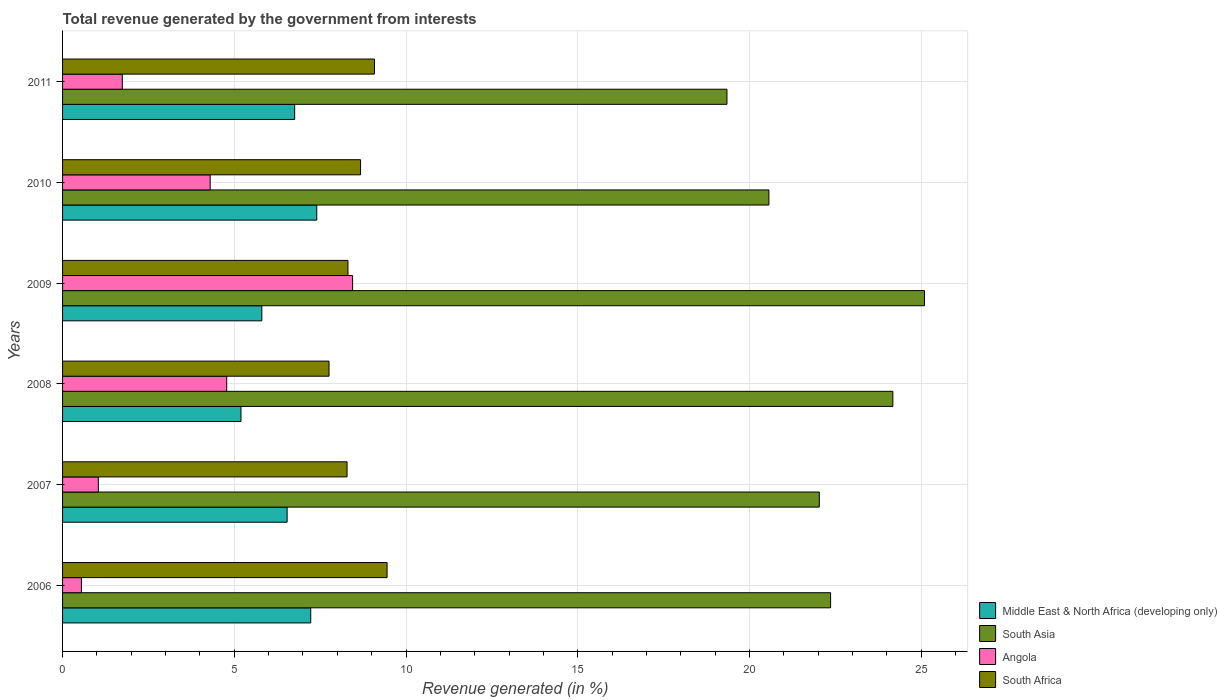Are the number of bars per tick equal to the number of legend labels?
Your answer should be very brief. Yes. Are the number of bars on each tick of the Y-axis equal?
Ensure brevity in your answer.  Yes. How many bars are there on the 1st tick from the top?
Offer a very short reply. 4. What is the total revenue generated in Angola in 2009?
Offer a terse response. 8.44. Across all years, what is the maximum total revenue generated in Middle East & North Africa (developing only)?
Ensure brevity in your answer.  7.4. Across all years, what is the minimum total revenue generated in South Asia?
Keep it short and to the point. 19.34. What is the total total revenue generated in South Africa in the graph?
Provide a succinct answer. 51.56. What is the difference between the total revenue generated in South Asia in 2007 and that in 2010?
Your answer should be very brief. 1.47. What is the difference between the total revenue generated in Middle East & North Africa (developing only) in 2010 and the total revenue generated in Angola in 2009?
Ensure brevity in your answer.  -1.04. What is the average total revenue generated in South Africa per year?
Offer a terse response. 8.59. In the year 2009, what is the difference between the total revenue generated in Middle East & North Africa (developing only) and total revenue generated in South Africa?
Provide a succinct answer. -2.51. What is the ratio of the total revenue generated in South Asia in 2009 to that in 2010?
Ensure brevity in your answer.  1.22. What is the difference between the highest and the second highest total revenue generated in South Asia?
Give a very brief answer. 0.92. What is the difference between the highest and the lowest total revenue generated in South Africa?
Your answer should be compact. 1.69. In how many years, is the total revenue generated in Angola greater than the average total revenue generated in Angola taken over all years?
Make the answer very short. 3. What does the 1st bar from the top in 2008 represents?
Your response must be concise. South Africa. Is it the case that in every year, the sum of the total revenue generated in South Africa and total revenue generated in Angola is greater than the total revenue generated in Middle East & North Africa (developing only)?
Your response must be concise. Yes. Are the values on the major ticks of X-axis written in scientific E-notation?
Provide a succinct answer. No. Where does the legend appear in the graph?
Ensure brevity in your answer.  Bottom right. How are the legend labels stacked?
Offer a very short reply. Vertical. What is the title of the graph?
Keep it short and to the point. Total revenue generated by the government from interests. What is the label or title of the X-axis?
Offer a very short reply. Revenue generated (in %). What is the Revenue generated (in %) in Middle East & North Africa (developing only) in 2006?
Your answer should be very brief. 7.23. What is the Revenue generated (in %) in South Asia in 2006?
Your answer should be compact. 22.36. What is the Revenue generated (in %) of Angola in 2006?
Offer a terse response. 0.55. What is the Revenue generated (in %) in South Africa in 2006?
Offer a terse response. 9.45. What is the Revenue generated (in %) of Middle East & North Africa (developing only) in 2007?
Your answer should be compact. 6.54. What is the Revenue generated (in %) in South Asia in 2007?
Make the answer very short. 22.03. What is the Revenue generated (in %) of Angola in 2007?
Offer a very short reply. 1.04. What is the Revenue generated (in %) of South Africa in 2007?
Your response must be concise. 8.28. What is the Revenue generated (in %) in Middle East & North Africa (developing only) in 2008?
Make the answer very short. 5.19. What is the Revenue generated (in %) of South Asia in 2008?
Your answer should be very brief. 24.17. What is the Revenue generated (in %) of Angola in 2008?
Provide a short and direct response. 4.78. What is the Revenue generated (in %) in South Africa in 2008?
Provide a succinct answer. 7.76. What is the Revenue generated (in %) of Middle East & North Africa (developing only) in 2009?
Offer a terse response. 5.8. What is the Revenue generated (in %) in South Asia in 2009?
Make the answer very short. 25.1. What is the Revenue generated (in %) in Angola in 2009?
Keep it short and to the point. 8.44. What is the Revenue generated (in %) in South Africa in 2009?
Your answer should be very brief. 8.31. What is the Revenue generated (in %) in Middle East & North Africa (developing only) in 2010?
Your answer should be very brief. 7.4. What is the Revenue generated (in %) of South Asia in 2010?
Provide a short and direct response. 20.57. What is the Revenue generated (in %) of Angola in 2010?
Keep it short and to the point. 4.3. What is the Revenue generated (in %) of South Africa in 2010?
Provide a succinct answer. 8.68. What is the Revenue generated (in %) in Middle East & North Africa (developing only) in 2011?
Keep it short and to the point. 6.76. What is the Revenue generated (in %) in South Asia in 2011?
Your response must be concise. 19.34. What is the Revenue generated (in %) of Angola in 2011?
Offer a very short reply. 1.74. What is the Revenue generated (in %) in South Africa in 2011?
Your answer should be very brief. 9.08. Across all years, what is the maximum Revenue generated (in %) in Middle East & North Africa (developing only)?
Give a very brief answer. 7.4. Across all years, what is the maximum Revenue generated (in %) of South Asia?
Ensure brevity in your answer.  25.1. Across all years, what is the maximum Revenue generated (in %) in Angola?
Offer a very short reply. 8.44. Across all years, what is the maximum Revenue generated (in %) in South Africa?
Provide a succinct answer. 9.45. Across all years, what is the minimum Revenue generated (in %) in Middle East & North Africa (developing only)?
Keep it short and to the point. 5.19. Across all years, what is the minimum Revenue generated (in %) of South Asia?
Keep it short and to the point. 19.34. Across all years, what is the minimum Revenue generated (in %) in Angola?
Provide a succinct answer. 0.55. Across all years, what is the minimum Revenue generated (in %) in South Africa?
Offer a very short reply. 7.76. What is the total Revenue generated (in %) in Middle East & North Africa (developing only) in the graph?
Offer a very short reply. 38.92. What is the total Revenue generated (in %) of South Asia in the graph?
Make the answer very short. 133.57. What is the total Revenue generated (in %) of Angola in the graph?
Offer a terse response. 20.85. What is the total Revenue generated (in %) in South Africa in the graph?
Offer a very short reply. 51.56. What is the difference between the Revenue generated (in %) in Middle East & North Africa (developing only) in 2006 and that in 2007?
Provide a short and direct response. 0.69. What is the difference between the Revenue generated (in %) in South Asia in 2006 and that in 2007?
Your answer should be very brief. 0.33. What is the difference between the Revenue generated (in %) of Angola in 2006 and that in 2007?
Your response must be concise. -0.49. What is the difference between the Revenue generated (in %) in South Africa in 2006 and that in 2007?
Ensure brevity in your answer.  1.17. What is the difference between the Revenue generated (in %) of Middle East & North Africa (developing only) in 2006 and that in 2008?
Give a very brief answer. 2.03. What is the difference between the Revenue generated (in %) in South Asia in 2006 and that in 2008?
Your answer should be very brief. -1.81. What is the difference between the Revenue generated (in %) of Angola in 2006 and that in 2008?
Keep it short and to the point. -4.23. What is the difference between the Revenue generated (in %) in South Africa in 2006 and that in 2008?
Make the answer very short. 1.69. What is the difference between the Revenue generated (in %) in Middle East & North Africa (developing only) in 2006 and that in 2009?
Give a very brief answer. 1.42. What is the difference between the Revenue generated (in %) of South Asia in 2006 and that in 2009?
Your answer should be compact. -2.73. What is the difference between the Revenue generated (in %) in Angola in 2006 and that in 2009?
Your answer should be compact. -7.89. What is the difference between the Revenue generated (in %) in South Africa in 2006 and that in 2009?
Provide a succinct answer. 1.14. What is the difference between the Revenue generated (in %) of Middle East & North Africa (developing only) in 2006 and that in 2010?
Offer a very short reply. -0.17. What is the difference between the Revenue generated (in %) in South Asia in 2006 and that in 2010?
Offer a very short reply. 1.8. What is the difference between the Revenue generated (in %) of Angola in 2006 and that in 2010?
Your response must be concise. -3.75. What is the difference between the Revenue generated (in %) in South Africa in 2006 and that in 2010?
Your answer should be very brief. 0.77. What is the difference between the Revenue generated (in %) in Middle East & North Africa (developing only) in 2006 and that in 2011?
Ensure brevity in your answer.  0.47. What is the difference between the Revenue generated (in %) of South Asia in 2006 and that in 2011?
Provide a short and direct response. 3.02. What is the difference between the Revenue generated (in %) of Angola in 2006 and that in 2011?
Your answer should be compact. -1.19. What is the difference between the Revenue generated (in %) of South Africa in 2006 and that in 2011?
Give a very brief answer. 0.37. What is the difference between the Revenue generated (in %) of Middle East & North Africa (developing only) in 2007 and that in 2008?
Your answer should be compact. 1.34. What is the difference between the Revenue generated (in %) of South Asia in 2007 and that in 2008?
Ensure brevity in your answer.  -2.14. What is the difference between the Revenue generated (in %) of Angola in 2007 and that in 2008?
Your response must be concise. -3.74. What is the difference between the Revenue generated (in %) of South Africa in 2007 and that in 2008?
Provide a short and direct response. 0.52. What is the difference between the Revenue generated (in %) of Middle East & North Africa (developing only) in 2007 and that in 2009?
Offer a very short reply. 0.74. What is the difference between the Revenue generated (in %) in South Asia in 2007 and that in 2009?
Make the answer very short. -3.06. What is the difference between the Revenue generated (in %) in Angola in 2007 and that in 2009?
Give a very brief answer. -7.4. What is the difference between the Revenue generated (in %) in South Africa in 2007 and that in 2009?
Provide a short and direct response. -0.03. What is the difference between the Revenue generated (in %) of Middle East & North Africa (developing only) in 2007 and that in 2010?
Your answer should be compact. -0.86. What is the difference between the Revenue generated (in %) in South Asia in 2007 and that in 2010?
Give a very brief answer. 1.47. What is the difference between the Revenue generated (in %) of Angola in 2007 and that in 2010?
Keep it short and to the point. -3.26. What is the difference between the Revenue generated (in %) of South Africa in 2007 and that in 2010?
Offer a terse response. -0.39. What is the difference between the Revenue generated (in %) in Middle East & North Africa (developing only) in 2007 and that in 2011?
Provide a short and direct response. -0.22. What is the difference between the Revenue generated (in %) of South Asia in 2007 and that in 2011?
Keep it short and to the point. 2.69. What is the difference between the Revenue generated (in %) in Angola in 2007 and that in 2011?
Your answer should be very brief. -0.7. What is the difference between the Revenue generated (in %) of South Africa in 2007 and that in 2011?
Ensure brevity in your answer.  -0.8. What is the difference between the Revenue generated (in %) of Middle East & North Africa (developing only) in 2008 and that in 2009?
Ensure brevity in your answer.  -0.61. What is the difference between the Revenue generated (in %) of South Asia in 2008 and that in 2009?
Ensure brevity in your answer.  -0.92. What is the difference between the Revenue generated (in %) in Angola in 2008 and that in 2009?
Provide a succinct answer. -3.66. What is the difference between the Revenue generated (in %) in South Africa in 2008 and that in 2009?
Offer a very short reply. -0.55. What is the difference between the Revenue generated (in %) in Middle East & North Africa (developing only) in 2008 and that in 2010?
Give a very brief answer. -2.21. What is the difference between the Revenue generated (in %) in South Asia in 2008 and that in 2010?
Offer a very short reply. 3.61. What is the difference between the Revenue generated (in %) in Angola in 2008 and that in 2010?
Offer a terse response. 0.48. What is the difference between the Revenue generated (in %) in South Africa in 2008 and that in 2010?
Provide a short and direct response. -0.92. What is the difference between the Revenue generated (in %) of Middle East & North Africa (developing only) in 2008 and that in 2011?
Ensure brevity in your answer.  -1.56. What is the difference between the Revenue generated (in %) of South Asia in 2008 and that in 2011?
Provide a succinct answer. 4.83. What is the difference between the Revenue generated (in %) in Angola in 2008 and that in 2011?
Give a very brief answer. 3.04. What is the difference between the Revenue generated (in %) in South Africa in 2008 and that in 2011?
Your answer should be compact. -1.32. What is the difference between the Revenue generated (in %) in Middle East & North Africa (developing only) in 2009 and that in 2010?
Give a very brief answer. -1.6. What is the difference between the Revenue generated (in %) in South Asia in 2009 and that in 2010?
Offer a terse response. 4.53. What is the difference between the Revenue generated (in %) in Angola in 2009 and that in 2010?
Give a very brief answer. 4.15. What is the difference between the Revenue generated (in %) in South Africa in 2009 and that in 2010?
Offer a very short reply. -0.37. What is the difference between the Revenue generated (in %) in Middle East & North Africa (developing only) in 2009 and that in 2011?
Your response must be concise. -0.96. What is the difference between the Revenue generated (in %) in South Asia in 2009 and that in 2011?
Give a very brief answer. 5.75. What is the difference between the Revenue generated (in %) of Angola in 2009 and that in 2011?
Offer a terse response. 6.7. What is the difference between the Revenue generated (in %) of South Africa in 2009 and that in 2011?
Give a very brief answer. -0.77. What is the difference between the Revenue generated (in %) in Middle East & North Africa (developing only) in 2010 and that in 2011?
Offer a very short reply. 0.64. What is the difference between the Revenue generated (in %) of South Asia in 2010 and that in 2011?
Your answer should be compact. 1.22. What is the difference between the Revenue generated (in %) in Angola in 2010 and that in 2011?
Provide a succinct answer. 2.56. What is the difference between the Revenue generated (in %) in South Africa in 2010 and that in 2011?
Keep it short and to the point. -0.41. What is the difference between the Revenue generated (in %) of Middle East & North Africa (developing only) in 2006 and the Revenue generated (in %) of South Asia in 2007?
Provide a succinct answer. -14.81. What is the difference between the Revenue generated (in %) of Middle East & North Africa (developing only) in 2006 and the Revenue generated (in %) of Angola in 2007?
Offer a terse response. 6.18. What is the difference between the Revenue generated (in %) of Middle East & North Africa (developing only) in 2006 and the Revenue generated (in %) of South Africa in 2007?
Your response must be concise. -1.06. What is the difference between the Revenue generated (in %) in South Asia in 2006 and the Revenue generated (in %) in Angola in 2007?
Keep it short and to the point. 21.32. What is the difference between the Revenue generated (in %) of South Asia in 2006 and the Revenue generated (in %) of South Africa in 2007?
Offer a terse response. 14.08. What is the difference between the Revenue generated (in %) in Angola in 2006 and the Revenue generated (in %) in South Africa in 2007?
Offer a terse response. -7.73. What is the difference between the Revenue generated (in %) in Middle East & North Africa (developing only) in 2006 and the Revenue generated (in %) in South Asia in 2008?
Make the answer very short. -16.95. What is the difference between the Revenue generated (in %) in Middle East & North Africa (developing only) in 2006 and the Revenue generated (in %) in Angola in 2008?
Keep it short and to the point. 2.45. What is the difference between the Revenue generated (in %) in Middle East & North Africa (developing only) in 2006 and the Revenue generated (in %) in South Africa in 2008?
Provide a short and direct response. -0.53. What is the difference between the Revenue generated (in %) in South Asia in 2006 and the Revenue generated (in %) in Angola in 2008?
Offer a very short reply. 17.58. What is the difference between the Revenue generated (in %) in South Asia in 2006 and the Revenue generated (in %) in South Africa in 2008?
Keep it short and to the point. 14.6. What is the difference between the Revenue generated (in %) of Angola in 2006 and the Revenue generated (in %) of South Africa in 2008?
Offer a very short reply. -7.21. What is the difference between the Revenue generated (in %) in Middle East & North Africa (developing only) in 2006 and the Revenue generated (in %) in South Asia in 2009?
Your answer should be very brief. -17.87. What is the difference between the Revenue generated (in %) of Middle East & North Africa (developing only) in 2006 and the Revenue generated (in %) of Angola in 2009?
Provide a succinct answer. -1.22. What is the difference between the Revenue generated (in %) of Middle East & North Africa (developing only) in 2006 and the Revenue generated (in %) of South Africa in 2009?
Offer a very short reply. -1.08. What is the difference between the Revenue generated (in %) in South Asia in 2006 and the Revenue generated (in %) in Angola in 2009?
Provide a short and direct response. 13.92. What is the difference between the Revenue generated (in %) in South Asia in 2006 and the Revenue generated (in %) in South Africa in 2009?
Your response must be concise. 14.05. What is the difference between the Revenue generated (in %) in Angola in 2006 and the Revenue generated (in %) in South Africa in 2009?
Offer a terse response. -7.76. What is the difference between the Revenue generated (in %) in Middle East & North Africa (developing only) in 2006 and the Revenue generated (in %) in South Asia in 2010?
Ensure brevity in your answer.  -13.34. What is the difference between the Revenue generated (in %) of Middle East & North Africa (developing only) in 2006 and the Revenue generated (in %) of Angola in 2010?
Make the answer very short. 2.93. What is the difference between the Revenue generated (in %) of Middle East & North Africa (developing only) in 2006 and the Revenue generated (in %) of South Africa in 2010?
Give a very brief answer. -1.45. What is the difference between the Revenue generated (in %) in South Asia in 2006 and the Revenue generated (in %) in Angola in 2010?
Give a very brief answer. 18.06. What is the difference between the Revenue generated (in %) of South Asia in 2006 and the Revenue generated (in %) of South Africa in 2010?
Make the answer very short. 13.69. What is the difference between the Revenue generated (in %) in Angola in 2006 and the Revenue generated (in %) in South Africa in 2010?
Keep it short and to the point. -8.13. What is the difference between the Revenue generated (in %) in Middle East & North Africa (developing only) in 2006 and the Revenue generated (in %) in South Asia in 2011?
Your answer should be compact. -12.12. What is the difference between the Revenue generated (in %) of Middle East & North Africa (developing only) in 2006 and the Revenue generated (in %) of Angola in 2011?
Give a very brief answer. 5.49. What is the difference between the Revenue generated (in %) of Middle East & North Africa (developing only) in 2006 and the Revenue generated (in %) of South Africa in 2011?
Offer a terse response. -1.86. What is the difference between the Revenue generated (in %) in South Asia in 2006 and the Revenue generated (in %) in Angola in 2011?
Keep it short and to the point. 20.62. What is the difference between the Revenue generated (in %) of South Asia in 2006 and the Revenue generated (in %) of South Africa in 2011?
Your answer should be compact. 13.28. What is the difference between the Revenue generated (in %) in Angola in 2006 and the Revenue generated (in %) in South Africa in 2011?
Your answer should be very brief. -8.53. What is the difference between the Revenue generated (in %) in Middle East & North Africa (developing only) in 2007 and the Revenue generated (in %) in South Asia in 2008?
Your response must be concise. -17.64. What is the difference between the Revenue generated (in %) of Middle East & North Africa (developing only) in 2007 and the Revenue generated (in %) of Angola in 2008?
Give a very brief answer. 1.76. What is the difference between the Revenue generated (in %) of Middle East & North Africa (developing only) in 2007 and the Revenue generated (in %) of South Africa in 2008?
Give a very brief answer. -1.22. What is the difference between the Revenue generated (in %) in South Asia in 2007 and the Revenue generated (in %) in Angola in 2008?
Provide a short and direct response. 17.25. What is the difference between the Revenue generated (in %) of South Asia in 2007 and the Revenue generated (in %) of South Africa in 2008?
Ensure brevity in your answer.  14.27. What is the difference between the Revenue generated (in %) in Angola in 2007 and the Revenue generated (in %) in South Africa in 2008?
Make the answer very short. -6.72. What is the difference between the Revenue generated (in %) of Middle East & North Africa (developing only) in 2007 and the Revenue generated (in %) of South Asia in 2009?
Offer a very short reply. -18.56. What is the difference between the Revenue generated (in %) of Middle East & North Africa (developing only) in 2007 and the Revenue generated (in %) of Angola in 2009?
Make the answer very short. -1.91. What is the difference between the Revenue generated (in %) of Middle East & North Africa (developing only) in 2007 and the Revenue generated (in %) of South Africa in 2009?
Your response must be concise. -1.77. What is the difference between the Revenue generated (in %) in South Asia in 2007 and the Revenue generated (in %) in Angola in 2009?
Make the answer very short. 13.59. What is the difference between the Revenue generated (in %) in South Asia in 2007 and the Revenue generated (in %) in South Africa in 2009?
Your answer should be very brief. 13.72. What is the difference between the Revenue generated (in %) in Angola in 2007 and the Revenue generated (in %) in South Africa in 2009?
Give a very brief answer. -7.27. What is the difference between the Revenue generated (in %) of Middle East & North Africa (developing only) in 2007 and the Revenue generated (in %) of South Asia in 2010?
Keep it short and to the point. -14.03. What is the difference between the Revenue generated (in %) in Middle East & North Africa (developing only) in 2007 and the Revenue generated (in %) in Angola in 2010?
Your answer should be very brief. 2.24. What is the difference between the Revenue generated (in %) in Middle East & North Africa (developing only) in 2007 and the Revenue generated (in %) in South Africa in 2010?
Provide a succinct answer. -2.14. What is the difference between the Revenue generated (in %) in South Asia in 2007 and the Revenue generated (in %) in Angola in 2010?
Your answer should be very brief. 17.73. What is the difference between the Revenue generated (in %) in South Asia in 2007 and the Revenue generated (in %) in South Africa in 2010?
Give a very brief answer. 13.36. What is the difference between the Revenue generated (in %) in Angola in 2007 and the Revenue generated (in %) in South Africa in 2010?
Make the answer very short. -7.63. What is the difference between the Revenue generated (in %) in Middle East & North Africa (developing only) in 2007 and the Revenue generated (in %) in South Asia in 2011?
Make the answer very short. -12.81. What is the difference between the Revenue generated (in %) in Middle East & North Africa (developing only) in 2007 and the Revenue generated (in %) in Angola in 2011?
Offer a very short reply. 4.8. What is the difference between the Revenue generated (in %) of Middle East & North Africa (developing only) in 2007 and the Revenue generated (in %) of South Africa in 2011?
Your response must be concise. -2.54. What is the difference between the Revenue generated (in %) of South Asia in 2007 and the Revenue generated (in %) of Angola in 2011?
Offer a very short reply. 20.29. What is the difference between the Revenue generated (in %) of South Asia in 2007 and the Revenue generated (in %) of South Africa in 2011?
Provide a short and direct response. 12.95. What is the difference between the Revenue generated (in %) in Angola in 2007 and the Revenue generated (in %) in South Africa in 2011?
Offer a very short reply. -8.04. What is the difference between the Revenue generated (in %) of Middle East & North Africa (developing only) in 2008 and the Revenue generated (in %) of South Asia in 2009?
Offer a terse response. -19.9. What is the difference between the Revenue generated (in %) in Middle East & North Africa (developing only) in 2008 and the Revenue generated (in %) in Angola in 2009?
Offer a terse response. -3.25. What is the difference between the Revenue generated (in %) of Middle East & North Africa (developing only) in 2008 and the Revenue generated (in %) of South Africa in 2009?
Offer a very short reply. -3.12. What is the difference between the Revenue generated (in %) in South Asia in 2008 and the Revenue generated (in %) in Angola in 2009?
Your answer should be very brief. 15.73. What is the difference between the Revenue generated (in %) of South Asia in 2008 and the Revenue generated (in %) of South Africa in 2009?
Make the answer very short. 15.86. What is the difference between the Revenue generated (in %) in Angola in 2008 and the Revenue generated (in %) in South Africa in 2009?
Your answer should be very brief. -3.53. What is the difference between the Revenue generated (in %) of Middle East & North Africa (developing only) in 2008 and the Revenue generated (in %) of South Asia in 2010?
Ensure brevity in your answer.  -15.37. What is the difference between the Revenue generated (in %) of Middle East & North Africa (developing only) in 2008 and the Revenue generated (in %) of Angola in 2010?
Offer a very short reply. 0.9. What is the difference between the Revenue generated (in %) in Middle East & North Africa (developing only) in 2008 and the Revenue generated (in %) in South Africa in 2010?
Offer a terse response. -3.48. What is the difference between the Revenue generated (in %) in South Asia in 2008 and the Revenue generated (in %) in Angola in 2010?
Provide a succinct answer. 19.88. What is the difference between the Revenue generated (in %) of South Asia in 2008 and the Revenue generated (in %) of South Africa in 2010?
Give a very brief answer. 15.5. What is the difference between the Revenue generated (in %) in Angola in 2008 and the Revenue generated (in %) in South Africa in 2010?
Give a very brief answer. -3.9. What is the difference between the Revenue generated (in %) in Middle East & North Africa (developing only) in 2008 and the Revenue generated (in %) in South Asia in 2011?
Provide a short and direct response. -14.15. What is the difference between the Revenue generated (in %) of Middle East & North Africa (developing only) in 2008 and the Revenue generated (in %) of Angola in 2011?
Keep it short and to the point. 3.45. What is the difference between the Revenue generated (in %) in Middle East & North Africa (developing only) in 2008 and the Revenue generated (in %) in South Africa in 2011?
Give a very brief answer. -3.89. What is the difference between the Revenue generated (in %) of South Asia in 2008 and the Revenue generated (in %) of Angola in 2011?
Your answer should be compact. 22.43. What is the difference between the Revenue generated (in %) of South Asia in 2008 and the Revenue generated (in %) of South Africa in 2011?
Ensure brevity in your answer.  15.09. What is the difference between the Revenue generated (in %) of Angola in 2008 and the Revenue generated (in %) of South Africa in 2011?
Ensure brevity in your answer.  -4.3. What is the difference between the Revenue generated (in %) of Middle East & North Africa (developing only) in 2009 and the Revenue generated (in %) of South Asia in 2010?
Provide a short and direct response. -14.76. What is the difference between the Revenue generated (in %) of Middle East & North Africa (developing only) in 2009 and the Revenue generated (in %) of Angola in 2010?
Keep it short and to the point. 1.5. What is the difference between the Revenue generated (in %) of Middle East & North Africa (developing only) in 2009 and the Revenue generated (in %) of South Africa in 2010?
Ensure brevity in your answer.  -2.87. What is the difference between the Revenue generated (in %) of South Asia in 2009 and the Revenue generated (in %) of Angola in 2010?
Offer a very short reply. 20.8. What is the difference between the Revenue generated (in %) in South Asia in 2009 and the Revenue generated (in %) in South Africa in 2010?
Keep it short and to the point. 16.42. What is the difference between the Revenue generated (in %) in Angola in 2009 and the Revenue generated (in %) in South Africa in 2010?
Ensure brevity in your answer.  -0.23. What is the difference between the Revenue generated (in %) in Middle East & North Africa (developing only) in 2009 and the Revenue generated (in %) in South Asia in 2011?
Your answer should be very brief. -13.54. What is the difference between the Revenue generated (in %) in Middle East & North Africa (developing only) in 2009 and the Revenue generated (in %) in Angola in 2011?
Offer a terse response. 4.06. What is the difference between the Revenue generated (in %) in Middle East & North Africa (developing only) in 2009 and the Revenue generated (in %) in South Africa in 2011?
Keep it short and to the point. -3.28. What is the difference between the Revenue generated (in %) of South Asia in 2009 and the Revenue generated (in %) of Angola in 2011?
Provide a succinct answer. 23.36. What is the difference between the Revenue generated (in %) in South Asia in 2009 and the Revenue generated (in %) in South Africa in 2011?
Your answer should be compact. 16.01. What is the difference between the Revenue generated (in %) of Angola in 2009 and the Revenue generated (in %) of South Africa in 2011?
Your answer should be very brief. -0.64. What is the difference between the Revenue generated (in %) in Middle East & North Africa (developing only) in 2010 and the Revenue generated (in %) in South Asia in 2011?
Provide a short and direct response. -11.94. What is the difference between the Revenue generated (in %) of Middle East & North Africa (developing only) in 2010 and the Revenue generated (in %) of Angola in 2011?
Ensure brevity in your answer.  5.66. What is the difference between the Revenue generated (in %) in Middle East & North Africa (developing only) in 2010 and the Revenue generated (in %) in South Africa in 2011?
Keep it short and to the point. -1.68. What is the difference between the Revenue generated (in %) of South Asia in 2010 and the Revenue generated (in %) of Angola in 2011?
Ensure brevity in your answer.  18.83. What is the difference between the Revenue generated (in %) of South Asia in 2010 and the Revenue generated (in %) of South Africa in 2011?
Provide a short and direct response. 11.48. What is the difference between the Revenue generated (in %) in Angola in 2010 and the Revenue generated (in %) in South Africa in 2011?
Your answer should be very brief. -4.78. What is the average Revenue generated (in %) of Middle East & North Africa (developing only) per year?
Ensure brevity in your answer.  6.49. What is the average Revenue generated (in %) of South Asia per year?
Offer a very short reply. 22.26. What is the average Revenue generated (in %) in Angola per year?
Your response must be concise. 3.48. What is the average Revenue generated (in %) of South Africa per year?
Provide a succinct answer. 8.59. In the year 2006, what is the difference between the Revenue generated (in %) of Middle East & North Africa (developing only) and Revenue generated (in %) of South Asia?
Give a very brief answer. -15.14. In the year 2006, what is the difference between the Revenue generated (in %) in Middle East & North Africa (developing only) and Revenue generated (in %) in Angola?
Keep it short and to the point. 6.68. In the year 2006, what is the difference between the Revenue generated (in %) of Middle East & North Africa (developing only) and Revenue generated (in %) of South Africa?
Provide a short and direct response. -2.22. In the year 2006, what is the difference between the Revenue generated (in %) of South Asia and Revenue generated (in %) of Angola?
Make the answer very short. 21.81. In the year 2006, what is the difference between the Revenue generated (in %) of South Asia and Revenue generated (in %) of South Africa?
Ensure brevity in your answer.  12.91. In the year 2006, what is the difference between the Revenue generated (in %) in Angola and Revenue generated (in %) in South Africa?
Offer a very short reply. -8.9. In the year 2007, what is the difference between the Revenue generated (in %) of Middle East & North Africa (developing only) and Revenue generated (in %) of South Asia?
Your answer should be compact. -15.49. In the year 2007, what is the difference between the Revenue generated (in %) in Middle East & North Africa (developing only) and Revenue generated (in %) in Angola?
Your answer should be very brief. 5.5. In the year 2007, what is the difference between the Revenue generated (in %) of Middle East & North Africa (developing only) and Revenue generated (in %) of South Africa?
Make the answer very short. -1.74. In the year 2007, what is the difference between the Revenue generated (in %) of South Asia and Revenue generated (in %) of Angola?
Offer a terse response. 20.99. In the year 2007, what is the difference between the Revenue generated (in %) of South Asia and Revenue generated (in %) of South Africa?
Give a very brief answer. 13.75. In the year 2007, what is the difference between the Revenue generated (in %) of Angola and Revenue generated (in %) of South Africa?
Your response must be concise. -7.24. In the year 2008, what is the difference between the Revenue generated (in %) in Middle East & North Africa (developing only) and Revenue generated (in %) in South Asia?
Provide a succinct answer. -18.98. In the year 2008, what is the difference between the Revenue generated (in %) of Middle East & North Africa (developing only) and Revenue generated (in %) of Angola?
Your answer should be compact. 0.41. In the year 2008, what is the difference between the Revenue generated (in %) of Middle East & North Africa (developing only) and Revenue generated (in %) of South Africa?
Ensure brevity in your answer.  -2.56. In the year 2008, what is the difference between the Revenue generated (in %) of South Asia and Revenue generated (in %) of Angola?
Offer a very short reply. 19.39. In the year 2008, what is the difference between the Revenue generated (in %) in South Asia and Revenue generated (in %) in South Africa?
Provide a succinct answer. 16.42. In the year 2008, what is the difference between the Revenue generated (in %) in Angola and Revenue generated (in %) in South Africa?
Offer a very short reply. -2.98. In the year 2009, what is the difference between the Revenue generated (in %) in Middle East & North Africa (developing only) and Revenue generated (in %) in South Asia?
Offer a very short reply. -19.29. In the year 2009, what is the difference between the Revenue generated (in %) of Middle East & North Africa (developing only) and Revenue generated (in %) of Angola?
Give a very brief answer. -2.64. In the year 2009, what is the difference between the Revenue generated (in %) in Middle East & North Africa (developing only) and Revenue generated (in %) in South Africa?
Offer a very short reply. -2.51. In the year 2009, what is the difference between the Revenue generated (in %) in South Asia and Revenue generated (in %) in Angola?
Ensure brevity in your answer.  16.65. In the year 2009, what is the difference between the Revenue generated (in %) of South Asia and Revenue generated (in %) of South Africa?
Your answer should be very brief. 16.79. In the year 2009, what is the difference between the Revenue generated (in %) in Angola and Revenue generated (in %) in South Africa?
Your answer should be very brief. 0.13. In the year 2010, what is the difference between the Revenue generated (in %) in Middle East & North Africa (developing only) and Revenue generated (in %) in South Asia?
Provide a succinct answer. -13.17. In the year 2010, what is the difference between the Revenue generated (in %) in Middle East & North Africa (developing only) and Revenue generated (in %) in Angola?
Provide a succinct answer. 3.1. In the year 2010, what is the difference between the Revenue generated (in %) in Middle East & North Africa (developing only) and Revenue generated (in %) in South Africa?
Your answer should be very brief. -1.28. In the year 2010, what is the difference between the Revenue generated (in %) in South Asia and Revenue generated (in %) in Angola?
Your answer should be compact. 16.27. In the year 2010, what is the difference between the Revenue generated (in %) of South Asia and Revenue generated (in %) of South Africa?
Your answer should be compact. 11.89. In the year 2010, what is the difference between the Revenue generated (in %) of Angola and Revenue generated (in %) of South Africa?
Your response must be concise. -4.38. In the year 2011, what is the difference between the Revenue generated (in %) of Middle East & North Africa (developing only) and Revenue generated (in %) of South Asia?
Keep it short and to the point. -12.59. In the year 2011, what is the difference between the Revenue generated (in %) in Middle East & North Africa (developing only) and Revenue generated (in %) in Angola?
Your answer should be compact. 5.02. In the year 2011, what is the difference between the Revenue generated (in %) in Middle East & North Africa (developing only) and Revenue generated (in %) in South Africa?
Offer a terse response. -2.32. In the year 2011, what is the difference between the Revenue generated (in %) in South Asia and Revenue generated (in %) in Angola?
Keep it short and to the point. 17.6. In the year 2011, what is the difference between the Revenue generated (in %) of South Asia and Revenue generated (in %) of South Africa?
Ensure brevity in your answer.  10.26. In the year 2011, what is the difference between the Revenue generated (in %) of Angola and Revenue generated (in %) of South Africa?
Your response must be concise. -7.34. What is the ratio of the Revenue generated (in %) of Middle East & North Africa (developing only) in 2006 to that in 2007?
Your answer should be compact. 1.11. What is the ratio of the Revenue generated (in %) in South Asia in 2006 to that in 2007?
Keep it short and to the point. 1.01. What is the ratio of the Revenue generated (in %) in Angola in 2006 to that in 2007?
Provide a succinct answer. 0.53. What is the ratio of the Revenue generated (in %) in South Africa in 2006 to that in 2007?
Your answer should be very brief. 1.14. What is the ratio of the Revenue generated (in %) in Middle East & North Africa (developing only) in 2006 to that in 2008?
Keep it short and to the point. 1.39. What is the ratio of the Revenue generated (in %) of South Asia in 2006 to that in 2008?
Your answer should be compact. 0.93. What is the ratio of the Revenue generated (in %) of Angola in 2006 to that in 2008?
Keep it short and to the point. 0.12. What is the ratio of the Revenue generated (in %) in South Africa in 2006 to that in 2008?
Your answer should be compact. 1.22. What is the ratio of the Revenue generated (in %) in Middle East & North Africa (developing only) in 2006 to that in 2009?
Your response must be concise. 1.25. What is the ratio of the Revenue generated (in %) of South Asia in 2006 to that in 2009?
Provide a short and direct response. 0.89. What is the ratio of the Revenue generated (in %) of Angola in 2006 to that in 2009?
Ensure brevity in your answer.  0.07. What is the ratio of the Revenue generated (in %) of South Africa in 2006 to that in 2009?
Provide a succinct answer. 1.14. What is the ratio of the Revenue generated (in %) of Middle East & North Africa (developing only) in 2006 to that in 2010?
Keep it short and to the point. 0.98. What is the ratio of the Revenue generated (in %) of South Asia in 2006 to that in 2010?
Provide a short and direct response. 1.09. What is the ratio of the Revenue generated (in %) of Angola in 2006 to that in 2010?
Provide a short and direct response. 0.13. What is the ratio of the Revenue generated (in %) of South Africa in 2006 to that in 2010?
Provide a short and direct response. 1.09. What is the ratio of the Revenue generated (in %) of Middle East & North Africa (developing only) in 2006 to that in 2011?
Keep it short and to the point. 1.07. What is the ratio of the Revenue generated (in %) in South Asia in 2006 to that in 2011?
Keep it short and to the point. 1.16. What is the ratio of the Revenue generated (in %) in Angola in 2006 to that in 2011?
Ensure brevity in your answer.  0.32. What is the ratio of the Revenue generated (in %) in South Africa in 2006 to that in 2011?
Give a very brief answer. 1.04. What is the ratio of the Revenue generated (in %) of Middle East & North Africa (developing only) in 2007 to that in 2008?
Keep it short and to the point. 1.26. What is the ratio of the Revenue generated (in %) of South Asia in 2007 to that in 2008?
Offer a very short reply. 0.91. What is the ratio of the Revenue generated (in %) of Angola in 2007 to that in 2008?
Keep it short and to the point. 0.22. What is the ratio of the Revenue generated (in %) in South Africa in 2007 to that in 2008?
Make the answer very short. 1.07. What is the ratio of the Revenue generated (in %) of Middle East & North Africa (developing only) in 2007 to that in 2009?
Provide a short and direct response. 1.13. What is the ratio of the Revenue generated (in %) in South Asia in 2007 to that in 2009?
Ensure brevity in your answer.  0.88. What is the ratio of the Revenue generated (in %) of Angola in 2007 to that in 2009?
Provide a short and direct response. 0.12. What is the ratio of the Revenue generated (in %) in South Africa in 2007 to that in 2009?
Offer a terse response. 1. What is the ratio of the Revenue generated (in %) of Middle East & North Africa (developing only) in 2007 to that in 2010?
Your answer should be compact. 0.88. What is the ratio of the Revenue generated (in %) in South Asia in 2007 to that in 2010?
Your answer should be very brief. 1.07. What is the ratio of the Revenue generated (in %) of Angola in 2007 to that in 2010?
Offer a terse response. 0.24. What is the ratio of the Revenue generated (in %) of South Africa in 2007 to that in 2010?
Give a very brief answer. 0.95. What is the ratio of the Revenue generated (in %) in Middle East & North Africa (developing only) in 2007 to that in 2011?
Your answer should be compact. 0.97. What is the ratio of the Revenue generated (in %) in South Asia in 2007 to that in 2011?
Offer a very short reply. 1.14. What is the ratio of the Revenue generated (in %) in Angola in 2007 to that in 2011?
Your response must be concise. 0.6. What is the ratio of the Revenue generated (in %) of South Africa in 2007 to that in 2011?
Make the answer very short. 0.91. What is the ratio of the Revenue generated (in %) of Middle East & North Africa (developing only) in 2008 to that in 2009?
Ensure brevity in your answer.  0.9. What is the ratio of the Revenue generated (in %) in South Asia in 2008 to that in 2009?
Offer a very short reply. 0.96. What is the ratio of the Revenue generated (in %) in Angola in 2008 to that in 2009?
Ensure brevity in your answer.  0.57. What is the ratio of the Revenue generated (in %) in South Africa in 2008 to that in 2009?
Give a very brief answer. 0.93. What is the ratio of the Revenue generated (in %) in Middle East & North Africa (developing only) in 2008 to that in 2010?
Make the answer very short. 0.7. What is the ratio of the Revenue generated (in %) in South Asia in 2008 to that in 2010?
Your answer should be compact. 1.18. What is the ratio of the Revenue generated (in %) in Angola in 2008 to that in 2010?
Keep it short and to the point. 1.11. What is the ratio of the Revenue generated (in %) in South Africa in 2008 to that in 2010?
Offer a very short reply. 0.89. What is the ratio of the Revenue generated (in %) in Middle East & North Africa (developing only) in 2008 to that in 2011?
Provide a succinct answer. 0.77. What is the ratio of the Revenue generated (in %) of South Asia in 2008 to that in 2011?
Provide a succinct answer. 1.25. What is the ratio of the Revenue generated (in %) of Angola in 2008 to that in 2011?
Make the answer very short. 2.75. What is the ratio of the Revenue generated (in %) of South Africa in 2008 to that in 2011?
Your answer should be compact. 0.85. What is the ratio of the Revenue generated (in %) of Middle East & North Africa (developing only) in 2009 to that in 2010?
Provide a succinct answer. 0.78. What is the ratio of the Revenue generated (in %) in South Asia in 2009 to that in 2010?
Offer a very short reply. 1.22. What is the ratio of the Revenue generated (in %) in Angola in 2009 to that in 2010?
Make the answer very short. 1.96. What is the ratio of the Revenue generated (in %) in South Africa in 2009 to that in 2010?
Keep it short and to the point. 0.96. What is the ratio of the Revenue generated (in %) in Middle East & North Africa (developing only) in 2009 to that in 2011?
Your response must be concise. 0.86. What is the ratio of the Revenue generated (in %) in South Asia in 2009 to that in 2011?
Provide a short and direct response. 1.3. What is the ratio of the Revenue generated (in %) in Angola in 2009 to that in 2011?
Your answer should be compact. 4.85. What is the ratio of the Revenue generated (in %) of South Africa in 2009 to that in 2011?
Offer a terse response. 0.92. What is the ratio of the Revenue generated (in %) of Middle East & North Africa (developing only) in 2010 to that in 2011?
Give a very brief answer. 1.1. What is the ratio of the Revenue generated (in %) in South Asia in 2010 to that in 2011?
Ensure brevity in your answer.  1.06. What is the ratio of the Revenue generated (in %) in Angola in 2010 to that in 2011?
Provide a succinct answer. 2.47. What is the ratio of the Revenue generated (in %) in South Africa in 2010 to that in 2011?
Your answer should be very brief. 0.96. What is the difference between the highest and the second highest Revenue generated (in %) of Middle East & North Africa (developing only)?
Your answer should be very brief. 0.17. What is the difference between the highest and the second highest Revenue generated (in %) of South Asia?
Your response must be concise. 0.92. What is the difference between the highest and the second highest Revenue generated (in %) of Angola?
Offer a terse response. 3.66. What is the difference between the highest and the second highest Revenue generated (in %) of South Africa?
Give a very brief answer. 0.37. What is the difference between the highest and the lowest Revenue generated (in %) in Middle East & North Africa (developing only)?
Your answer should be compact. 2.21. What is the difference between the highest and the lowest Revenue generated (in %) in South Asia?
Offer a terse response. 5.75. What is the difference between the highest and the lowest Revenue generated (in %) in Angola?
Offer a terse response. 7.89. What is the difference between the highest and the lowest Revenue generated (in %) of South Africa?
Your response must be concise. 1.69. 